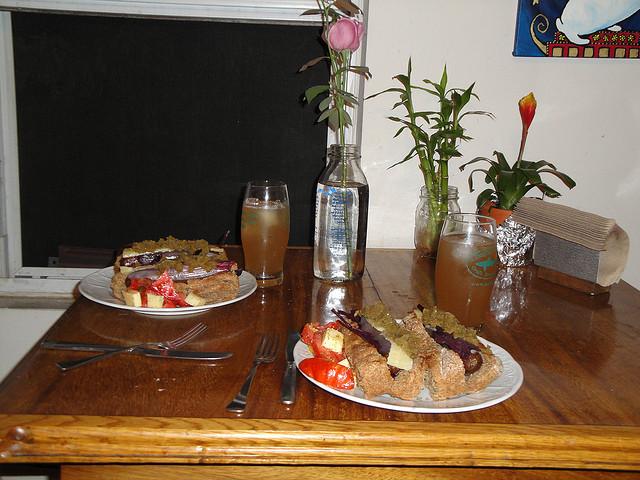Is this a vegetarian meal?
Quick response, please. No. What kind of fruit is on the plate?
Be succinct. Tomato. Are the flowers both the same kind?
Concise answer only. No. What is that entree called?
Concise answer only. Hot dogs. Are the candles lit?
Short answer required. No. Is there food on the table?
Be succinct. Yes. How are the utensils on the left positioned?
Concise answer only. Crossed. 